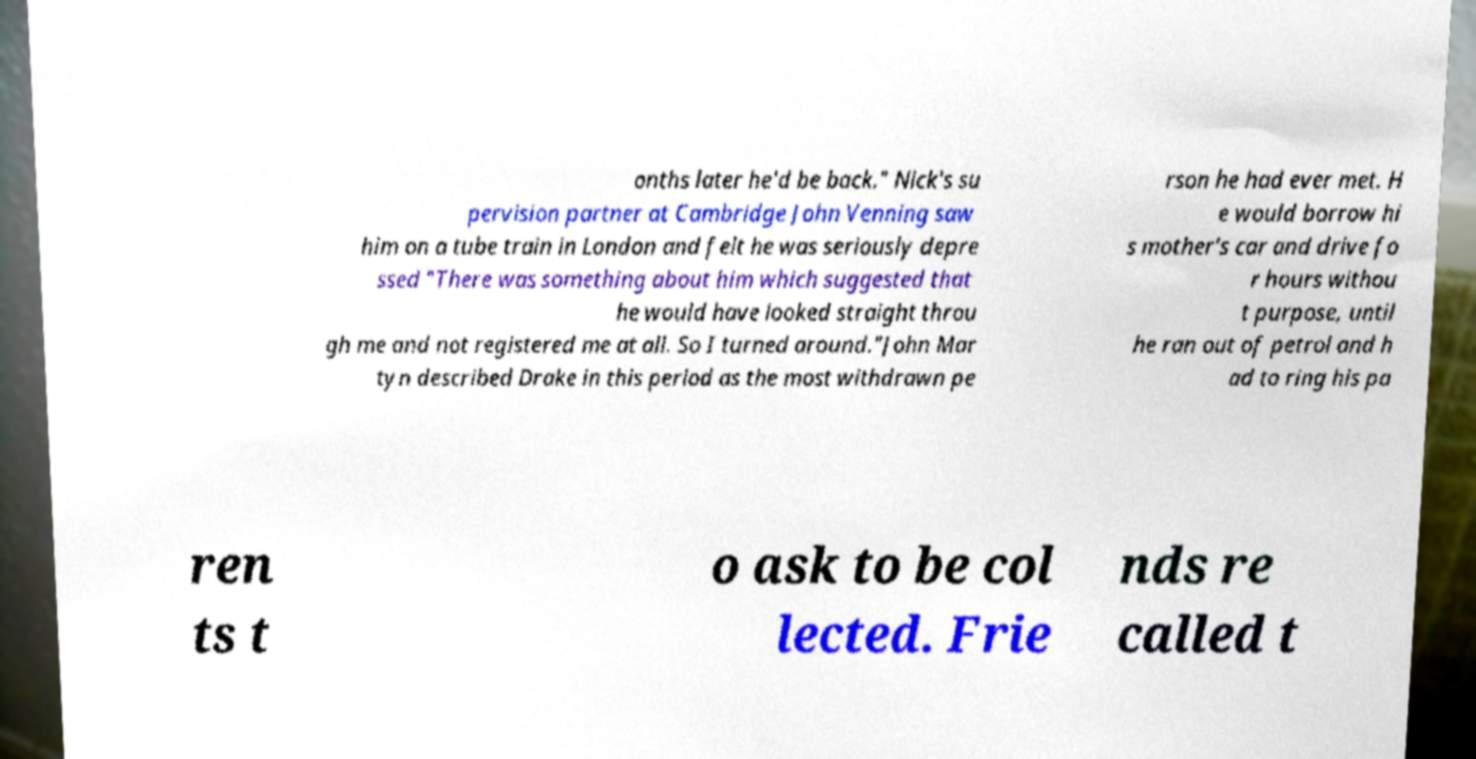Could you assist in decoding the text presented in this image and type it out clearly? onths later he'd be back." Nick's su pervision partner at Cambridge John Venning saw him on a tube train in London and felt he was seriously depre ssed "There was something about him which suggested that he would have looked straight throu gh me and not registered me at all. So I turned around."John Mar tyn described Drake in this period as the most withdrawn pe rson he had ever met. H e would borrow hi s mother's car and drive fo r hours withou t purpose, until he ran out of petrol and h ad to ring his pa ren ts t o ask to be col lected. Frie nds re called t 